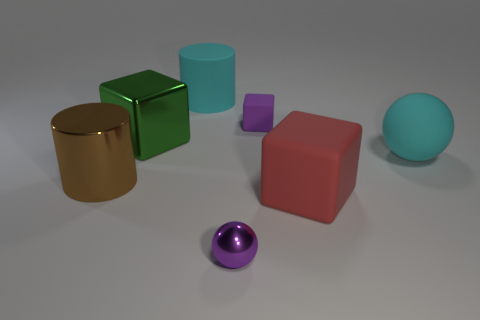Add 2 rubber things. How many objects exist? 9 Subtract all balls. How many objects are left? 5 Subtract 0 gray cubes. How many objects are left? 7 Subtract all large brown objects. Subtract all large red matte things. How many objects are left? 5 Add 3 big cyan matte spheres. How many big cyan matte spheres are left? 4 Add 4 metallic balls. How many metallic balls exist? 5 